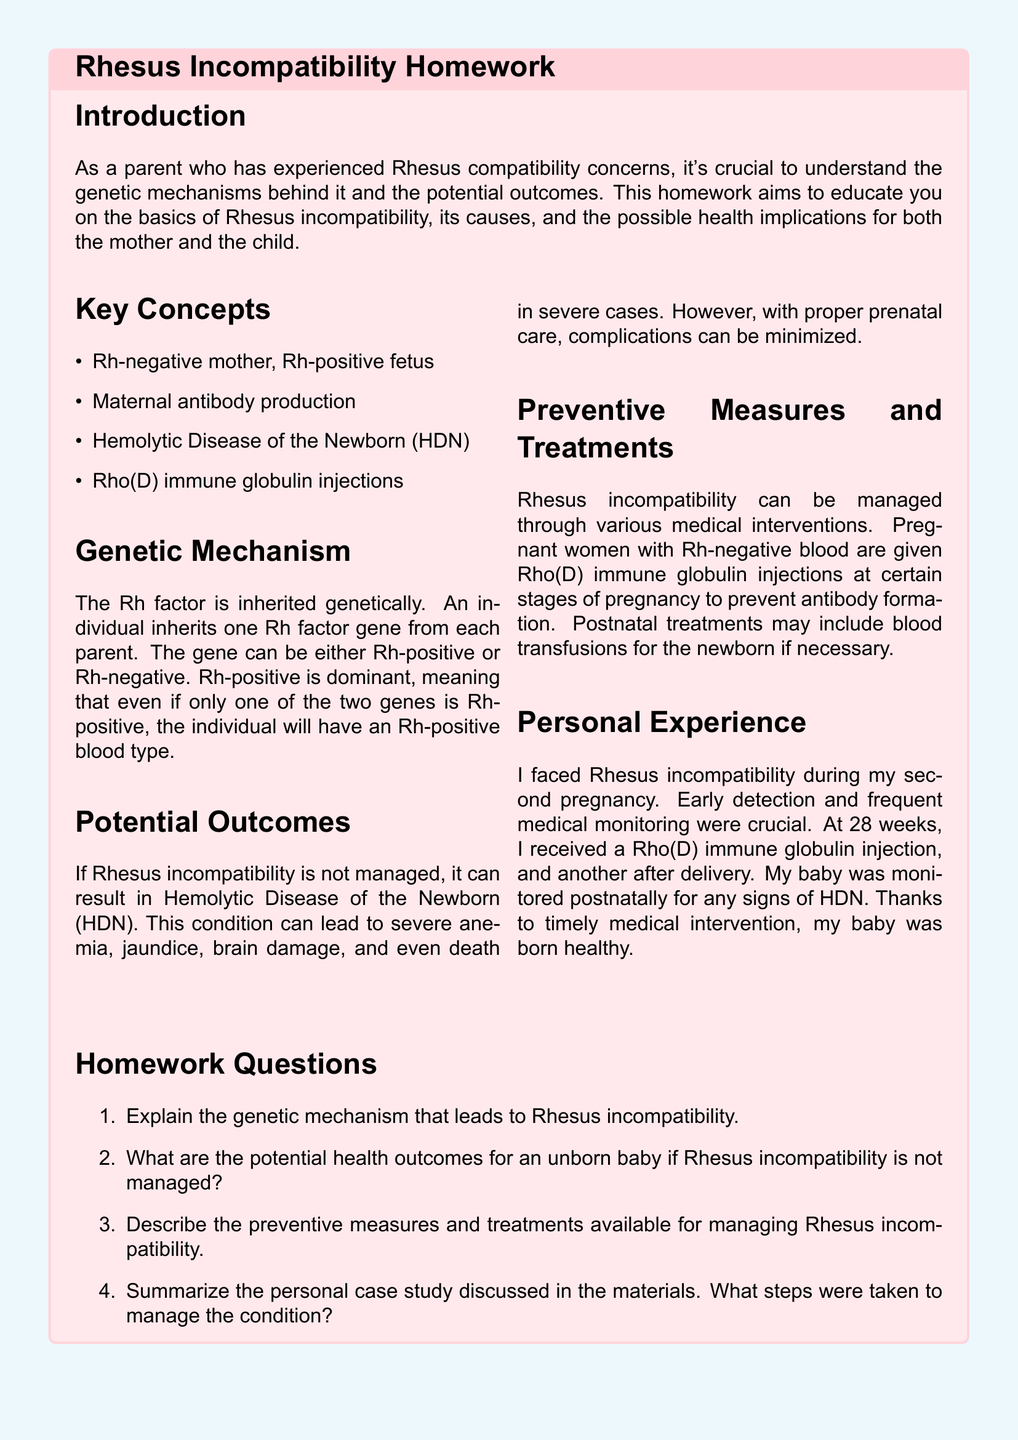What is the Rh factor? The Rh factor is a protein that can be present on the surface of red blood cells.
Answer: A protein What does Rh-positive mean? Rh-positive means that an individual has at least one Rh-positive gene, making them have Rh-positive blood type.
Answer: At least one Rh-positive gene What is HDN? HDN stands for Hemolytic Disease of the Newborn, a condition resulting from Rhesus incompatibility.
Answer: Hemolytic Disease of the Newborn What are Rho(D) immune globulin injections used for? Rho(D) immune globulin injections are used to prevent antibody formation in Rh-negative mothers.
Answer: Prevent antibody formation What health outcome can occur if Rhesus incompatibility is not managed? Severe anemia can occur if Rhesus incompatibility is not managed.
Answer: Severe anemia What was administered to the mother at 28 weeks of pregnancy? The mother received a Rho(D) immune globulin injection.
Answer: Rho(D) immune globulin injection What is the consequence of Rh-negative mothers having Rh-positive fetuses? Rh-negative mothers having Rh-positive fetuses can lead to maternal antibody production.
Answer: Maternal antibody production What is a key preventive measure for Rhesus incompatibility? A key preventive measure is administering Rho(D) immune globulin injections.
Answer: Rho(D) immune globulin injections What personal experience is discussed in the document? The personal experience discussed is of facing Rhesus incompatibility during a second pregnancy.
Answer: Facing Rhesus incompatibility during a second pregnancy 